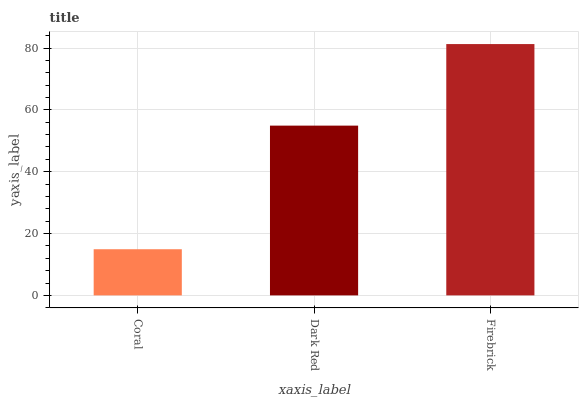Is Coral the minimum?
Answer yes or no. Yes. Is Firebrick the maximum?
Answer yes or no. Yes. Is Dark Red the minimum?
Answer yes or no. No. Is Dark Red the maximum?
Answer yes or no. No. Is Dark Red greater than Coral?
Answer yes or no. Yes. Is Coral less than Dark Red?
Answer yes or no. Yes. Is Coral greater than Dark Red?
Answer yes or no. No. Is Dark Red less than Coral?
Answer yes or no. No. Is Dark Red the high median?
Answer yes or no. Yes. Is Dark Red the low median?
Answer yes or no. Yes. Is Coral the high median?
Answer yes or no. No. Is Firebrick the low median?
Answer yes or no. No. 